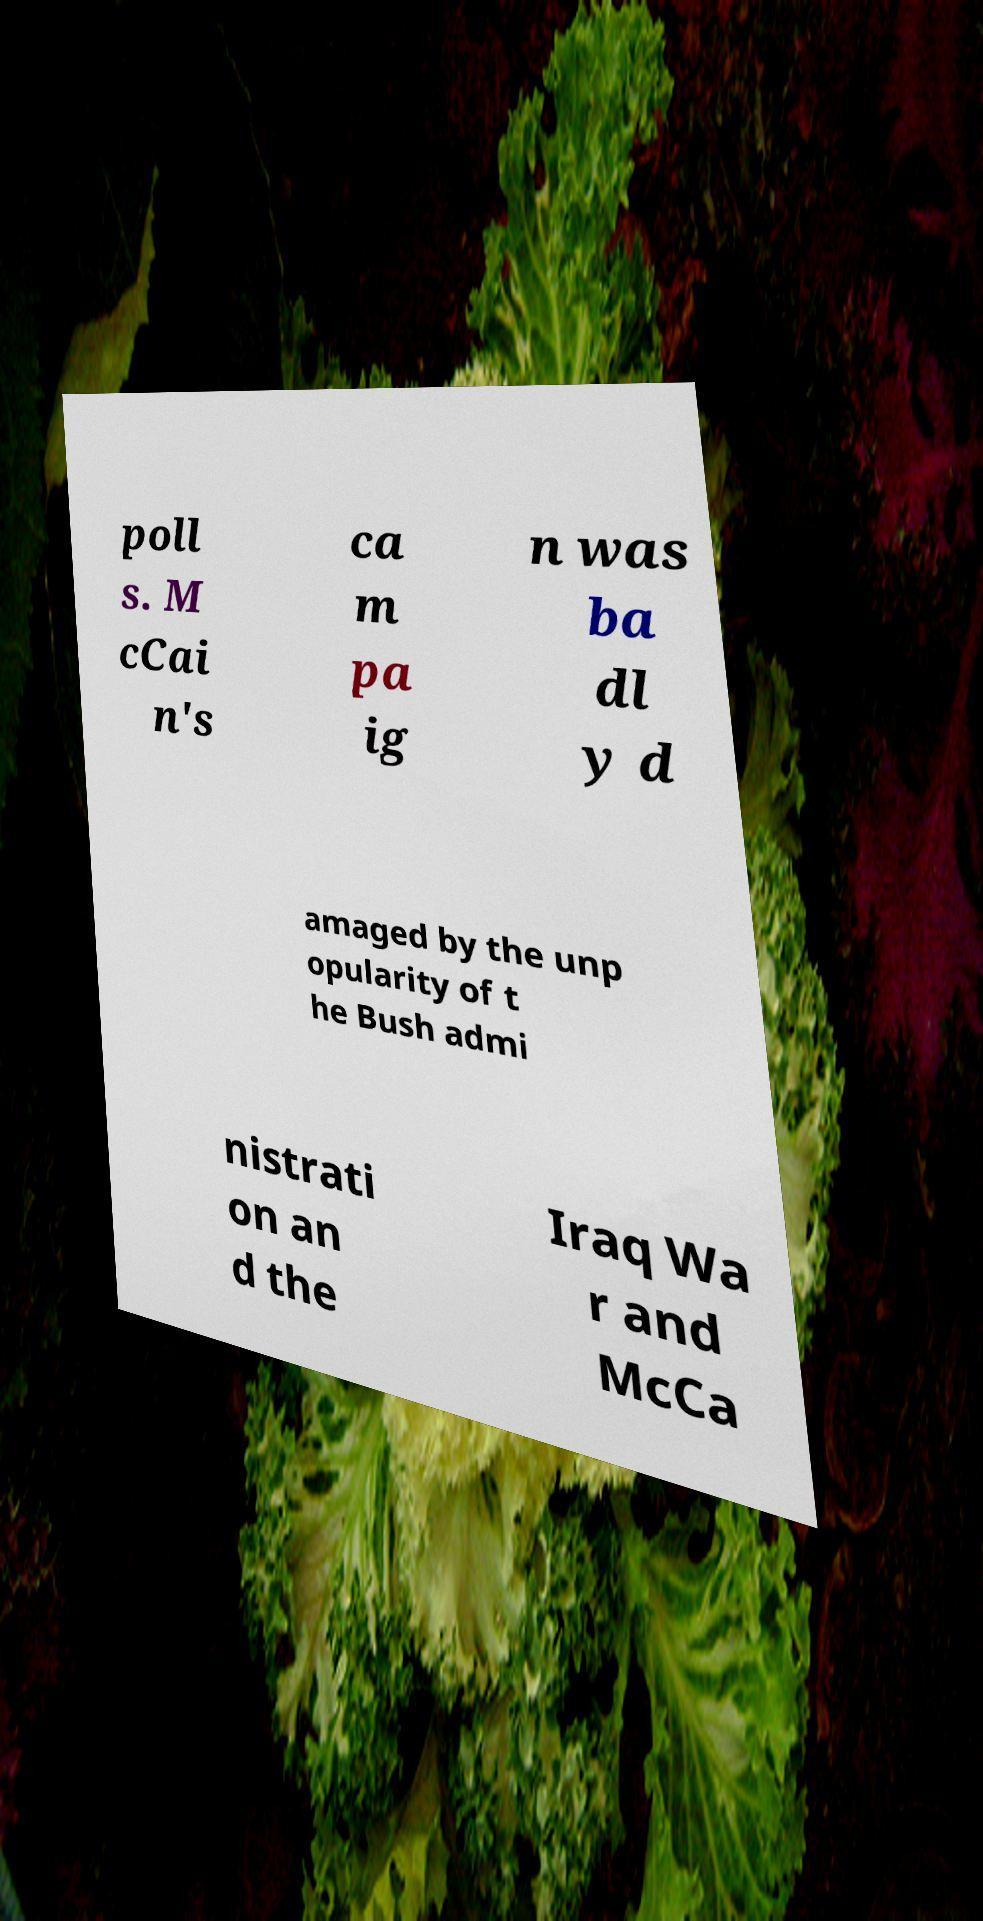Please read and relay the text visible in this image. What does it say? poll s. M cCai n's ca m pa ig n was ba dl y d amaged by the unp opularity of t he Bush admi nistrati on an d the Iraq Wa r and McCa 